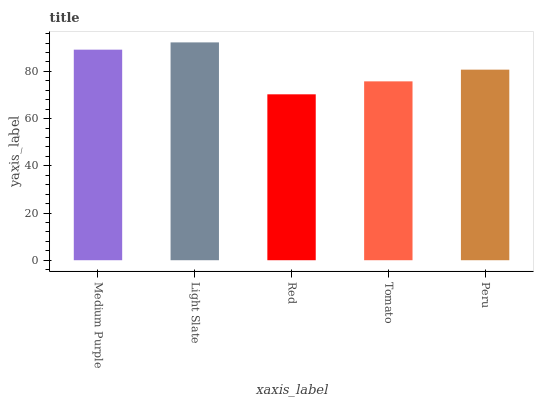Is Red the minimum?
Answer yes or no. Yes. Is Light Slate the maximum?
Answer yes or no. Yes. Is Light Slate the minimum?
Answer yes or no. No. Is Red the maximum?
Answer yes or no. No. Is Light Slate greater than Red?
Answer yes or no. Yes. Is Red less than Light Slate?
Answer yes or no. Yes. Is Red greater than Light Slate?
Answer yes or no. No. Is Light Slate less than Red?
Answer yes or no. No. Is Peru the high median?
Answer yes or no. Yes. Is Peru the low median?
Answer yes or no. Yes. Is Red the high median?
Answer yes or no. No. Is Light Slate the low median?
Answer yes or no. No. 